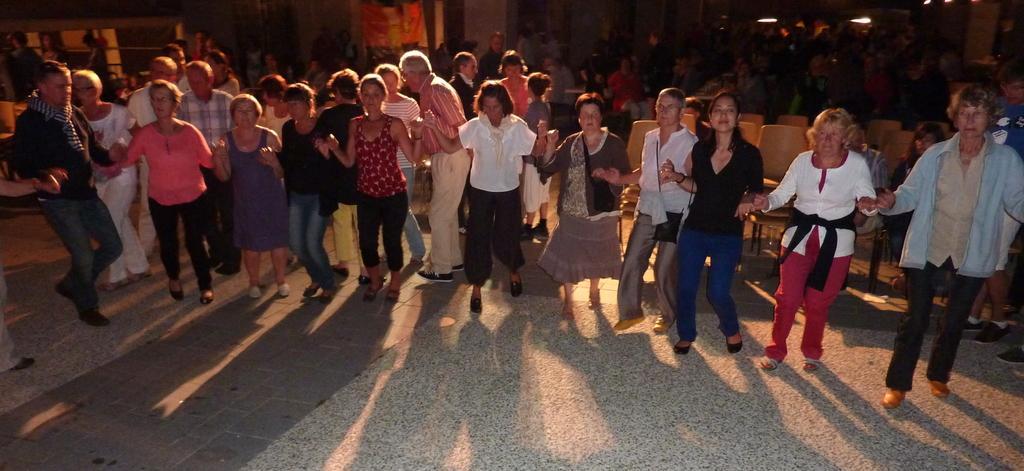How would you summarize this image in a sentence or two? In this image, there are a few people. We can see the ground and some chairs. We can also see the wall with an object. 